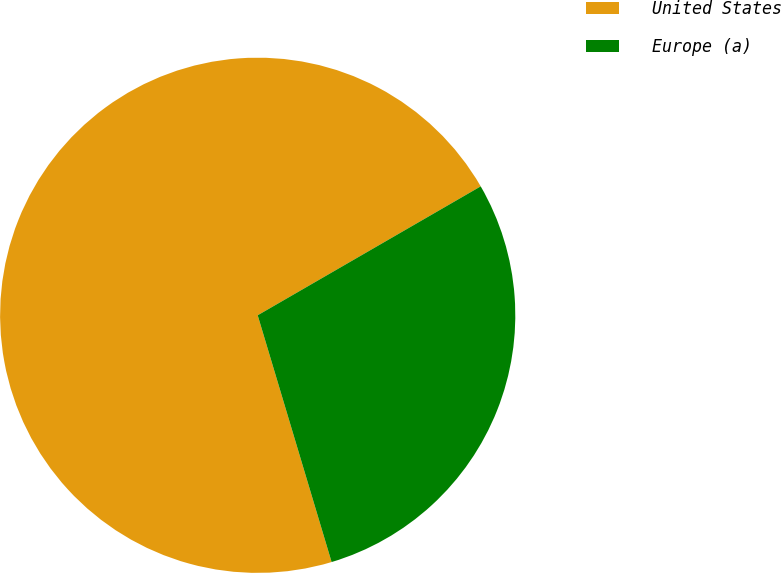Convert chart to OTSL. <chart><loc_0><loc_0><loc_500><loc_500><pie_chart><fcel>United States<fcel>Europe (a)<nl><fcel>71.29%<fcel>28.71%<nl></chart> 